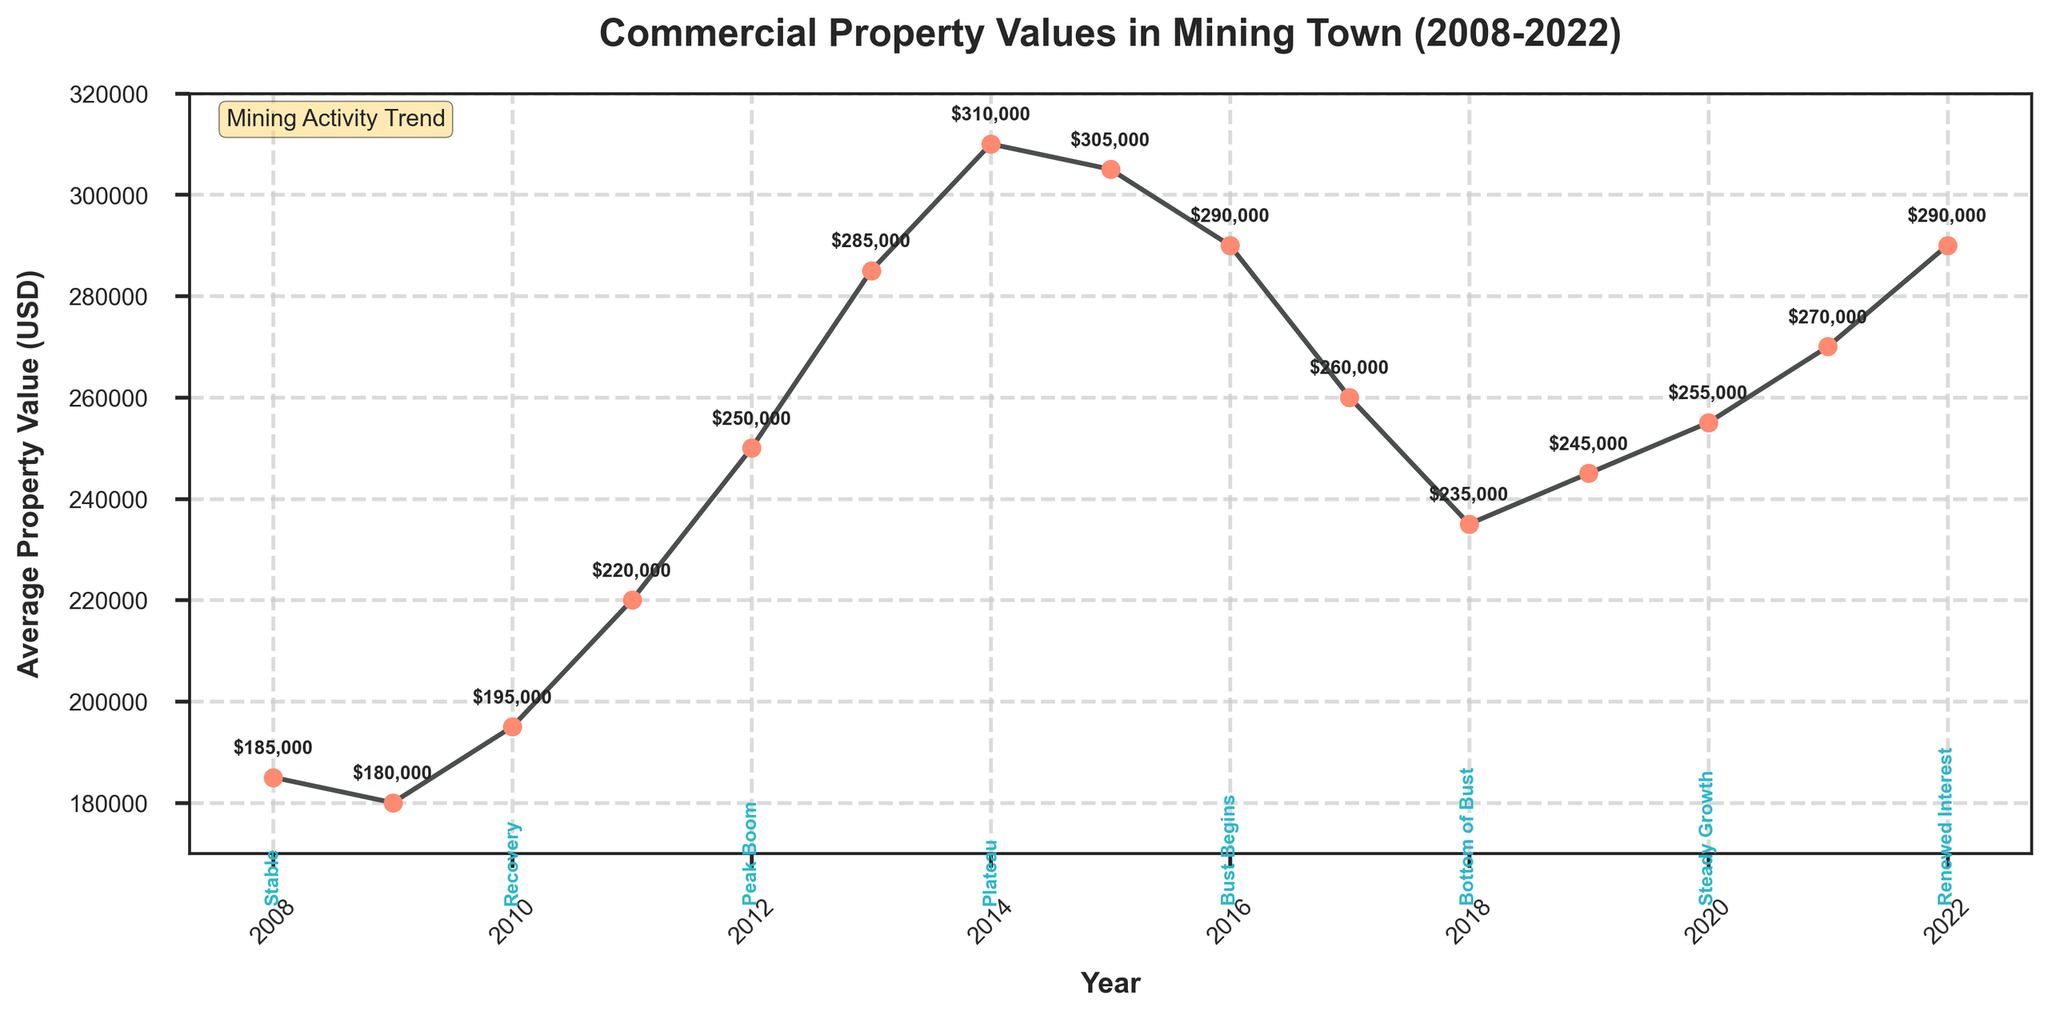How much did the average property value increase from the bottom of the bust in 2018 to the renewed interest in 2022? The average property value in 2018 was $235,000, and in 2022 it was $290,000. The increase is calculated as $290,000 - $235,000 = $55,000.
Answer: $55,000 What was the average property value during the peak boom period in 2012? In 2012, the average property value was annotated directly above the corresponding data point on the plot, showing it as $250,000.
Answer: $250,000 Which year had the highest average property value, and what was the value? The highest average property value is shown at the highest peak of the line, which occurred in 2014, with a value of $310,000.
Answer: 2014, $310,000 By how much did the property value decrease from the Plateau period in 2014 to the bottom of the bust in 2018? The average property value in 2014 was $310,000, and in 2018 it was $235,000. The decrease is calculated as $310,000 - $235,000 = $75,000.
Answer: $75,000 Which period experienced a more significant decline, from the peak boom in 2012 to the slight decline in 2015, or from the beginning of the bust in 2016 to the bottom of the bust in 2018? The decline from 2012 to 2015: $250,000 (2012) to $305,000 (2015) = $55,000. The decline from 2016 to 2018: $290,000 (2016) to $235,000 (2018) = $55,000. Both periods experienced the same decline of $55,000.
Answer: Same decline What is the difference in average property value between the year a new deposit was found and the year of early recovery? The average property value in 2021 (new deposits found) was $270,000, and in 2019 (early recovery) was $245,000. The difference is calculated as $270,000 - $245,000 = $25,000.
Answer: $25,000 In which years did the mining town experience early recovery, and what were the average property values during those years? The early recovery happened in 2019, and the property value was $245,000.
Answer: 2019, $245,000 What was the average property value change between steady growth in 2020 and renewed interest in 2022? The average property value in 2020 was $255,000, and in 2022 it was $290,000. The change is calculated as $290,000 - $255,000 = $35,000.
Answer: $35,000 